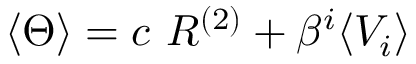Convert formula to latex. <formula><loc_0><loc_0><loc_500><loc_500>\langle \Theta \rangle = c R ^ { ( 2 ) } + \beta ^ { i } \langle V _ { i } \rangle</formula> 